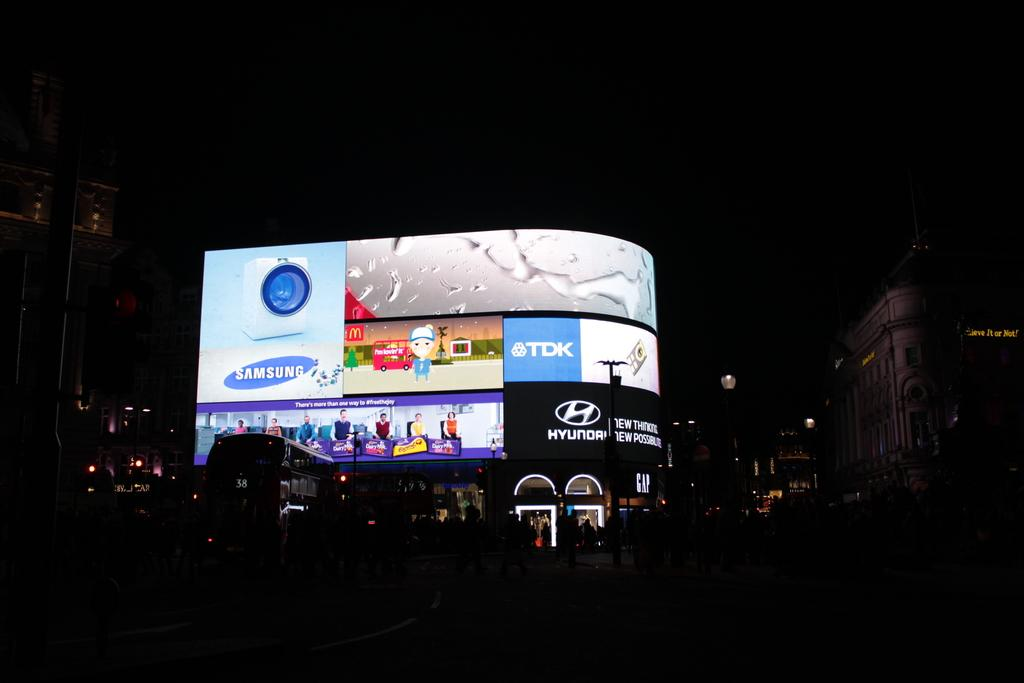Provide a one-sentence caption for the provided image. An illuminated billboard with many adverts, one of which is for Samsung. 